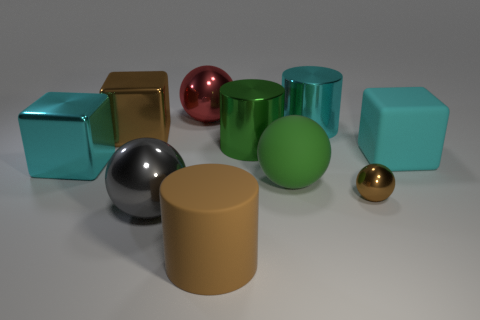Subtract all cyan matte blocks. How many blocks are left? 2 Subtract all yellow cylinders. How many cyan cubes are left? 2 Subtract all brown cylinders. How many cylinders are left? 2 Subtract all red blocks. Subtract all gray spheres. How many blocks are left? 3 Subtract 0 purple cylinders. How many objects are left? 10 Subtract all cylinders. How many objects are left? 7 Subtract 1 blocks. How many blocks are left? 2 Subtract all gray balls. Subtract all green rubber spheres. How many objects are left? 8 Add 5 rubber balls. How many rubber balls are left? 6 Add 7 big brown metal objects. How many big brown metal objects exist? 8 